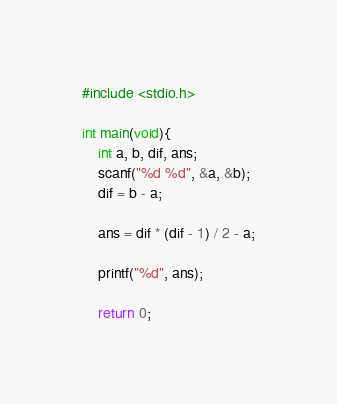Convert code to text. <code><loc_0><loc_0><loc_500><loc_500><_C_>#include <stdio.h>

int main(void){
    int a, b, dif, ans;
    scanf("%d %d", &a, &b);
    dif = b - a;
    
    ans = dif * (dif - 1) / 2 - a;
    
    printf("%d", ans);
    
    return 0;</code> 